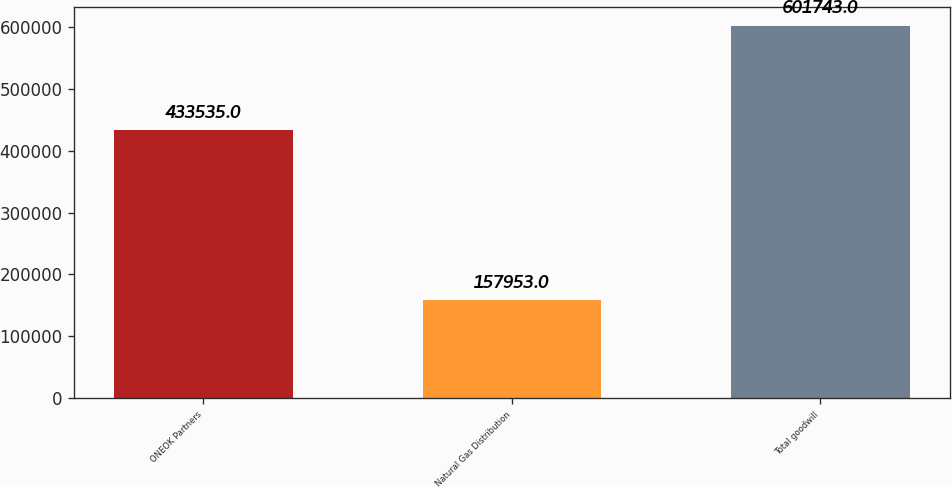Convert chart to OTSL. <chart><loc_0><loc_0><loc_500><loc_500><bar_chart><fcel>ONEOK Partners<fcel>Natural Gas Distribution<fcel>Total goodwill<nl><fcel>433535<fcel>157953<fcel>601743<nl></chart> 